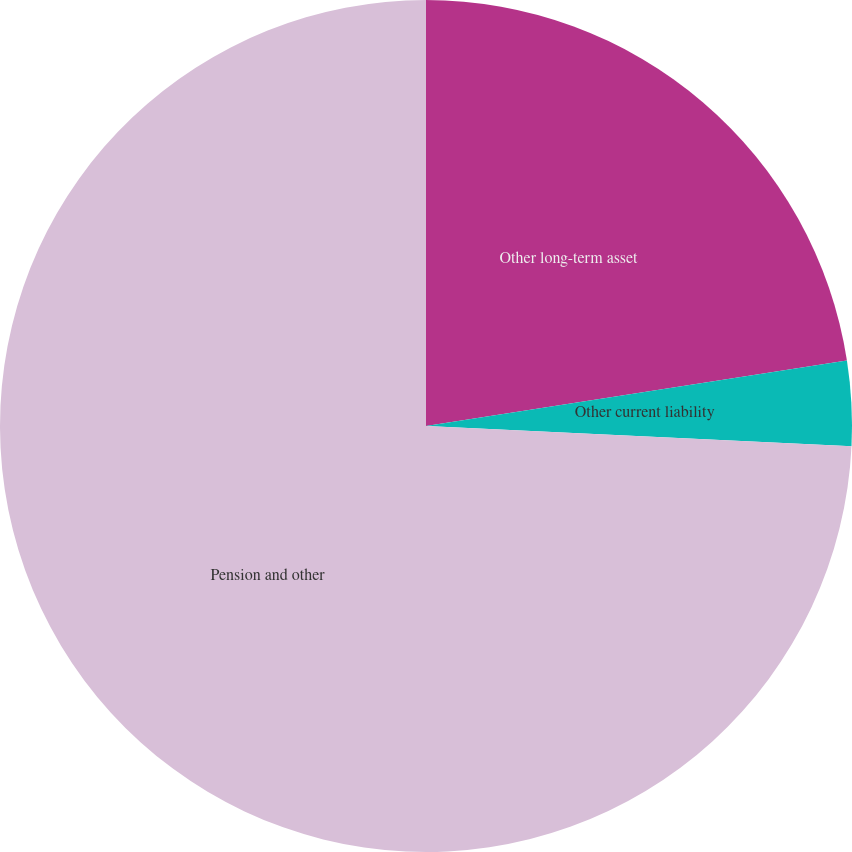<chart> <loc_0><loc_0><loc_500><loc_500><pie_chart><fcel>Other long-term asset<fcel>Other current liability<fcel>Pension and other<nl><fcel>22.54%<fcel>3.21%<fcel>74.24%<nl></chart> 